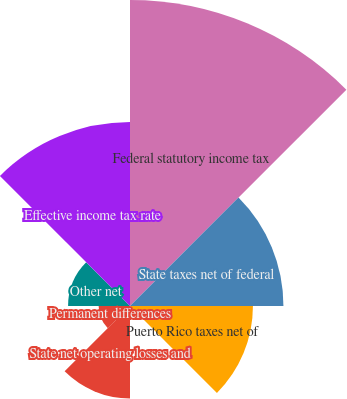<chart> <loc_0><loc_0><loc_500><loc_500><pie_chart><fcel>Federal statutory income tax<fcel>State taxes net of federal<fcel>Puerto Rico taxes net of<fcel>Change in valuation allowance<fcel>State net operating losses and<fcel>Permanent differences<fcel>Other net<fcel>Effective income tax rate<nl><fcel>32.11%<fcel>16.1%<fcel>12.9%<fcel>0.09%<fcel>9.7%<fcel>3.29%<fcel>6.5%<fcel>19.3%<nl></chart> 